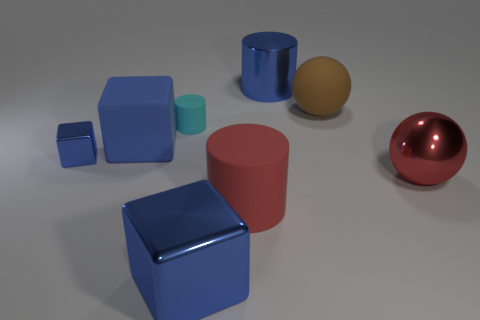Can you tell me more about the shapes and count of the objects? Certainly. There are six distinct objects in the image, each with a different shape. From left to right, we have a small blue cube, a larger blue cube, a small aqua-blue cylinder, a large pink cylinder, a golden-yellow sphere, and a large red shiny sphere. The objects are positioned on a flat surface and vary in size, color, and reflectivity. 